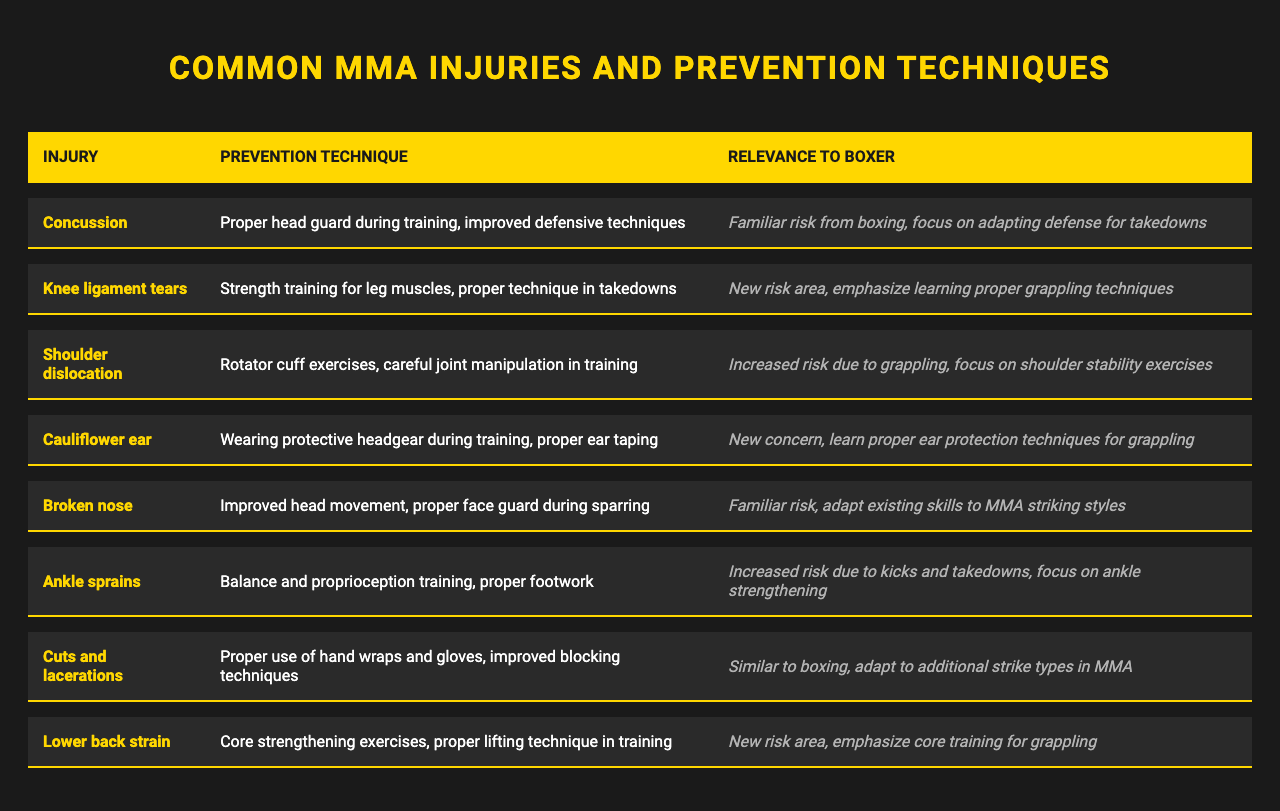What is the most common injury in MMA according to the table? The table lists several injuries, and the first injury listed is "Concussion," which indicates it is a notable common injury in MMA.
Answer: Concussion What prevention technique is recommended for knee ligament tears? The table specifies "Strength training for leg muscles, proper technique in takedowns" as the prevention technique for knee ligament tears.
Answer: Strength training for leg muscles, proper technique in takedowns Is "Cauliflower ear" mentioned as a common injury in MMA? Yes, the table lists "Cauliflower ear" as one of the common injuries in MMA.
Answer: Yes What is a recommended technique to prevent shoulder dislocation? The prevention technique listed for shoulder dislocation is "Rotator cuff exercises, careful joint manipulation in training."
Answer: Rotator cuff exercises, careful joint manipulation in training Which injuries have a focus on learning proper techniques or exercises? Both "Knee ligament tears" and "Lower back strain" emphasize learning proper grappling techniques or core training, respectively, indicating a focus on techniques/exercises.
Answer: Knee ligament tears and lower back strain Based on the table, which injury may occur due to kicks and takedowns, according to the prevention technique? "Ankle sprains" is specifically highlighted with focus on "Balance and proprioception training, proper footwork," indicating its relation to kicks and takedowns.
Answer: Ankle sprains What is the prevention technique listed for broken noses? The prevention technique for broken noses is "Improved head movement, proper face guard during sparring."
Answer: Improved head movement, proper face guard during sparring Which injuries are indicated as having familiar risks for someone coming from boxing? "Concussion" and "Broken nose" are both injuries with familiar risks for a boxer, as noted in their respective relevance in the table.
Answer: Concussion and broken nose What is the relationship between cuts and lacerations and boxing? The table states that "Cuts and lacerations" are similar to boxing and suggest adapting to additional strike types in MMA, which highlights this relationship.
Answer: They are similar to boxing; adapt to additional strike types in MMA How do prevention techniques for MMA injuries compare to typical boxing injuries? Many prevention techniques for MMA injuries, such as "Proper use of hand wraps and gloves," mirror boxing practices but also account for grappling and striking differences.
Answer: They are comparable but account for differences in grappling and striking 